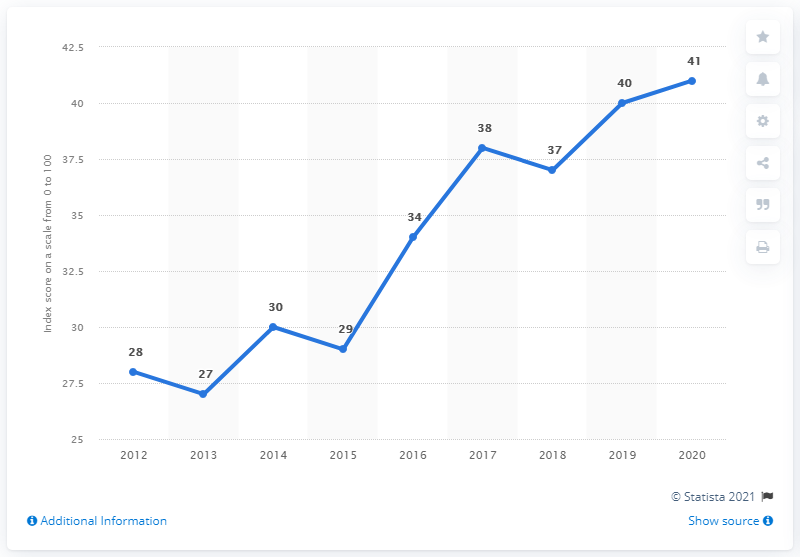Outline some significant characteristics in this image. Guyana's corruption perception index score in 2020 was 41, indicating a moderate level of perceived corruption in the country. 